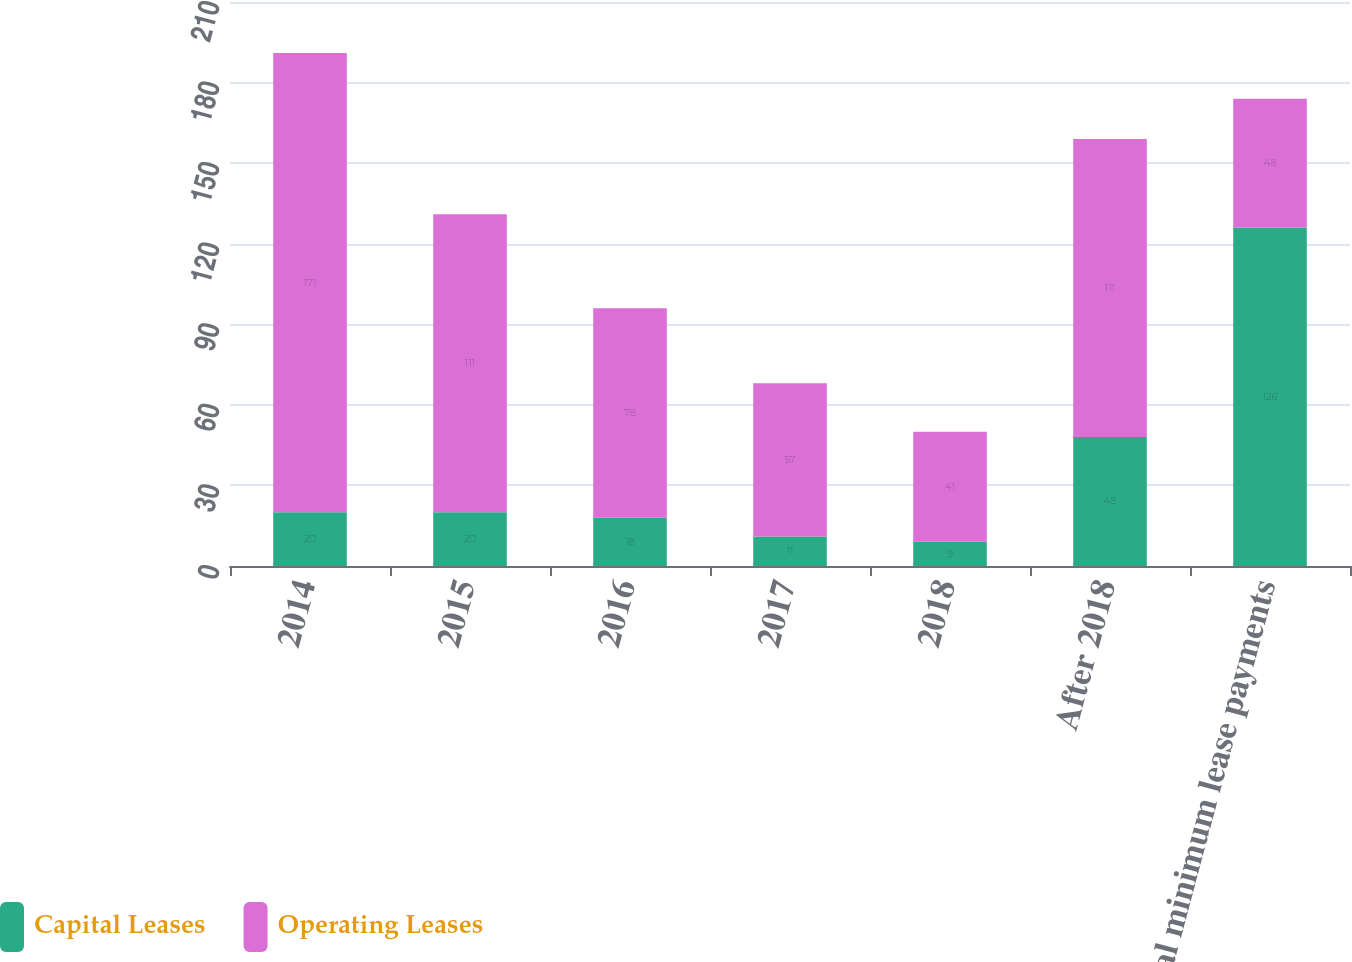Convert chart. <chart><loc_0><loc_0><loc_500><loc_500><stacked_bar_chart><ecel><fcel>2014<fcel>2015<fcel>2016<fcel>2017<fcel>2018<fcel>After 2018<fcel>Total minimum lease payments<nl><fcel>Capital Leases<fcel>20<fcel>20<fcel>18<fcel>11<fcel>9<fcel>48<fcel>126<nl><fcel>Operating Leases<fcel>171<fcel>111<fcel>78<fcel>57<fcel>41<fcel>111<fcel>48<nl></chart> 